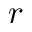Convert formula to latex. <formula><loc_0><loc_0><loc_500><loc_500>r</formula> 